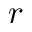Convert formula to latex. <formula><loc_0><loc_0><loc_500><loc_500>r</formula> 